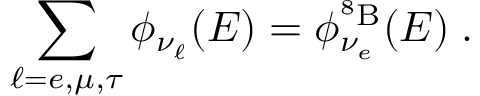Convert formula to latex. <formula><loc_0><loc_0><loc_500><loc_500>\sum _ { \ell = e , \mu , \tau } \phi _ { \nu _ { \ell } } ( E ) = \phi _ { \nu _ { e } } ^ { ^ { 8 } B } ( E ) \, .</formula> 